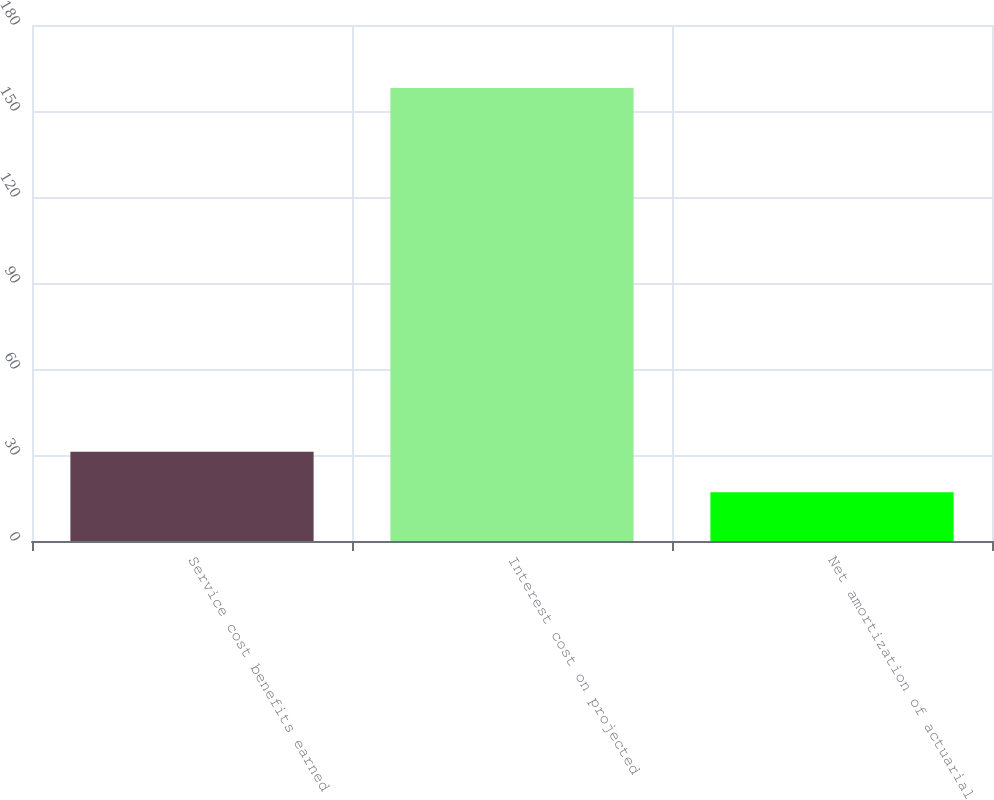<chart> <loc_0><loc_0><loc_500><loc_500><bar_chart><fcel>Service cost benefits earned<fcel>Interest cost on projected<fcel>Net amortization of actuarial<nl><fcel>31.1<fcel>158<fcel>17<nl></chart> 